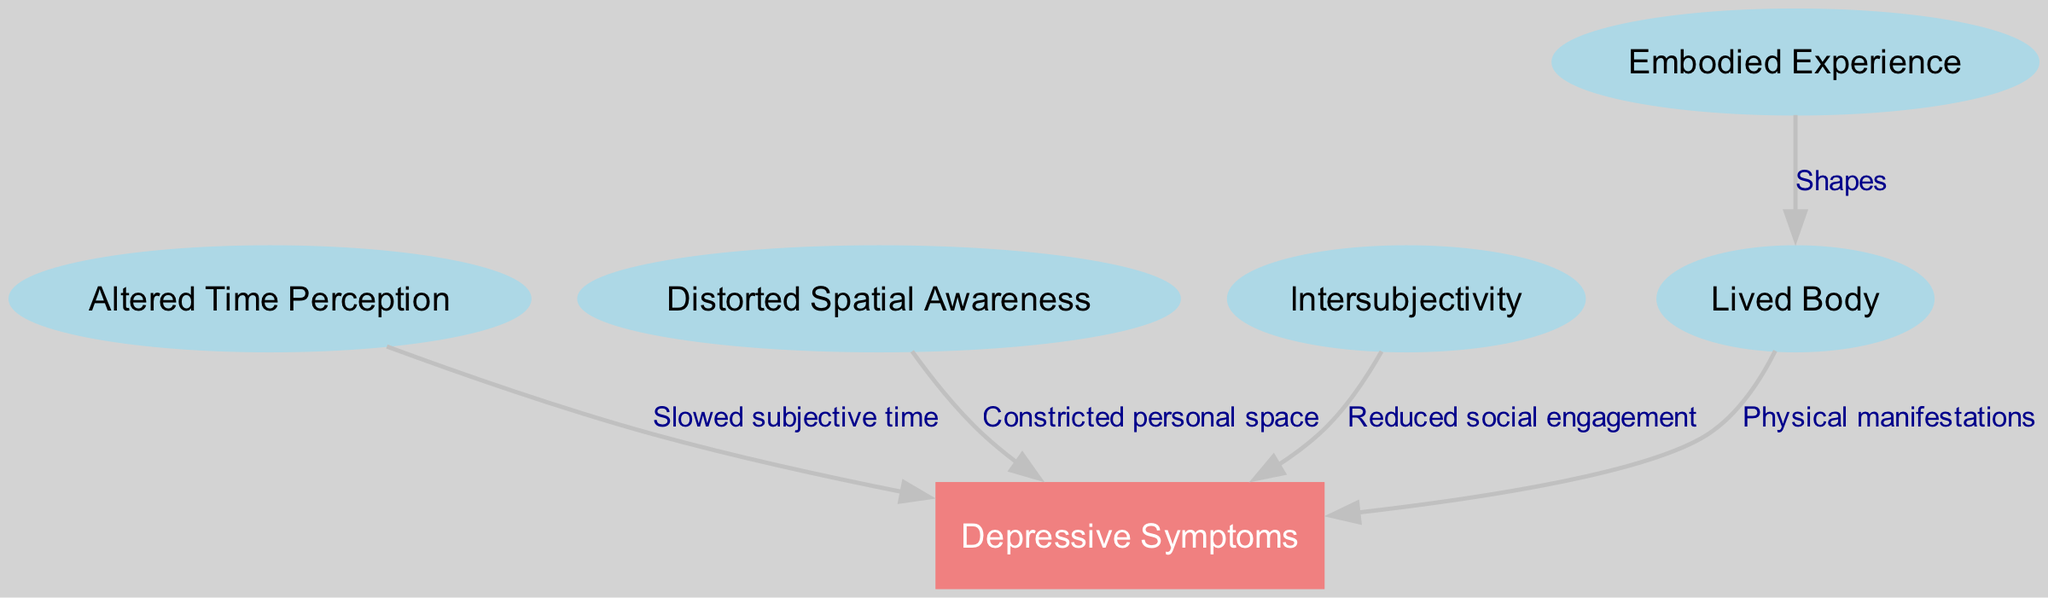What is the central node in the diagram? The central node is "Depressive Symptoms," which is visually distinct as it is in a box and has multiple connections to other nodes, making it prominent in the diagram.
Answer: Depressive Symptoms How many nodes are in the diagram? By counting the unique labels in the diagram, there are 6 nodes: Altered Time Perception, Distorted Spatial Awareness, Embodied Experience, Intersubjectivity, Lived Body, and Depressive Symptoms.
Answer: 6 What does the edge from "Altered Time Perception" to "Depressive Symptoms" represent? This edge represents the relationship labeled "Slowed subjective time," connecting how altered time perception contributes to depressive symptoms, indicating a causal link.
Answer: Slowed subjective time Which node is connected to "Intersubjectivity"? The "Intersubjectivity" node connects to the "Depressive Symptoms" node. There’s an edge drawn between them, representing the effect of reduced social engagement on depressive symptoms.
Answer: Depressive Symptoms What is the relationship between "Embodied Experience" and "Lived Body"? The relationship represented by the edge between "Embodied Experience" and "Lived Body" is labeled "Shapes," indicating a connection in how embodiment is perceived in relation to the lived body.
Answer: Shapes What type of awareness does "Distorted Spatial Awareness" refer to? The "Distorted Spatial Awareness" node refers specifically to "Constricted personal space," indicating a limited perception of one's environment, which is a common symptom of depression affecting spatial awareness.
Answer: Constricted personal space Describe the overall connection of "Lived Body" to "Depressive Symptoms." The "Lived Body" connects to "Depressive Symptoms" through the edge labeled "Physical manifestations," showing how physical sensations in the lived body may contribute to or manifest as depressive symptoms.
Answer: Physical manifestations How many edges are originating from "Depressive Symptoms"? There are four edges originating from "Depressive Symptoms," which connect it to altered time perception, distorted spatial awareness, intersubjectivity, and lived body, representing different ways symptoms can manifest.
Answer: 4 What common theme do all edges leading into "Depressive Symptoms" share? All edges leading into "Depressive Symptoms" indicate various phenomenological aspects of lived experience that contribute to or can exacerbate depressive symptoms, illustrating the complex interplay of factors involved.
Answer: Phenomenological aspects 